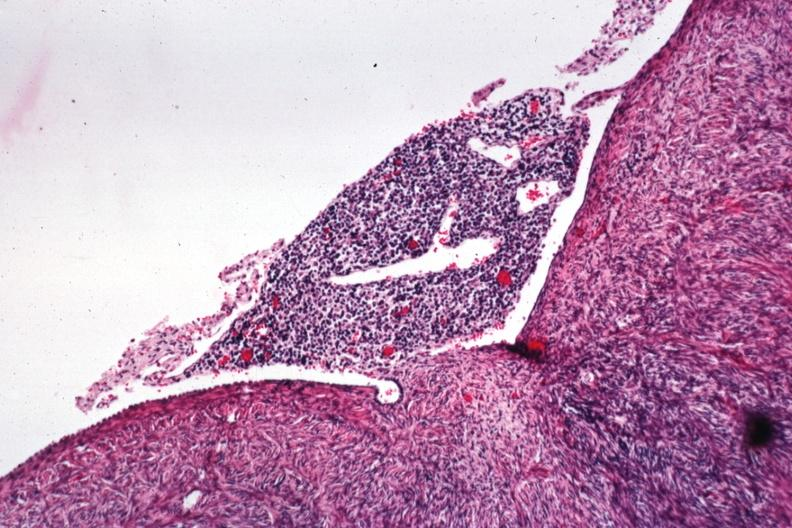s ovary present?
Answer the question using a single word or phrase. Yes 